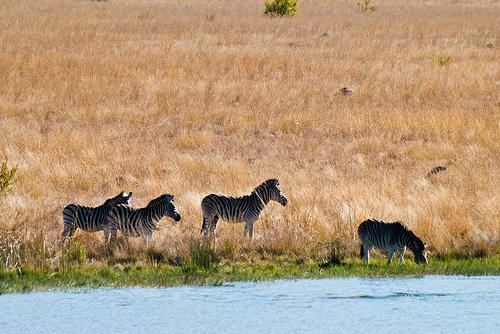Question: what is in front of the grass?
Choices:
A. Water.
B. Stones.
C. Dirt.
D. Trees.
Answer with the letter. Answer: A Question: what color are the zebras?
Choices:
A. Tan.
B. Orange.
C. Black and white.
D. Blue.
Answer with the letter. Answer: C Question: how many zebras are there?
Choices:
A. 5.
B. 4.
C. 6.
D. 7.
Answer with the letter. Answer: B Question: what color is the grass?
Choices:
A. Black.
B. Yellow.
C. Orange.
D. Green.
Answer with the letter. Answer: D Question: what are the zebras standing on?
Choices:
A. Sand.
B. Clay.
C. Rocks.
D. Grass.
Answer with the letter. Answer: D Question: where was the picture taken?
Choices:
A. At a park.
B. At a play.
C. At the movies.
D. In a wildlife refuge.
Answer with the letter. Answer: D 